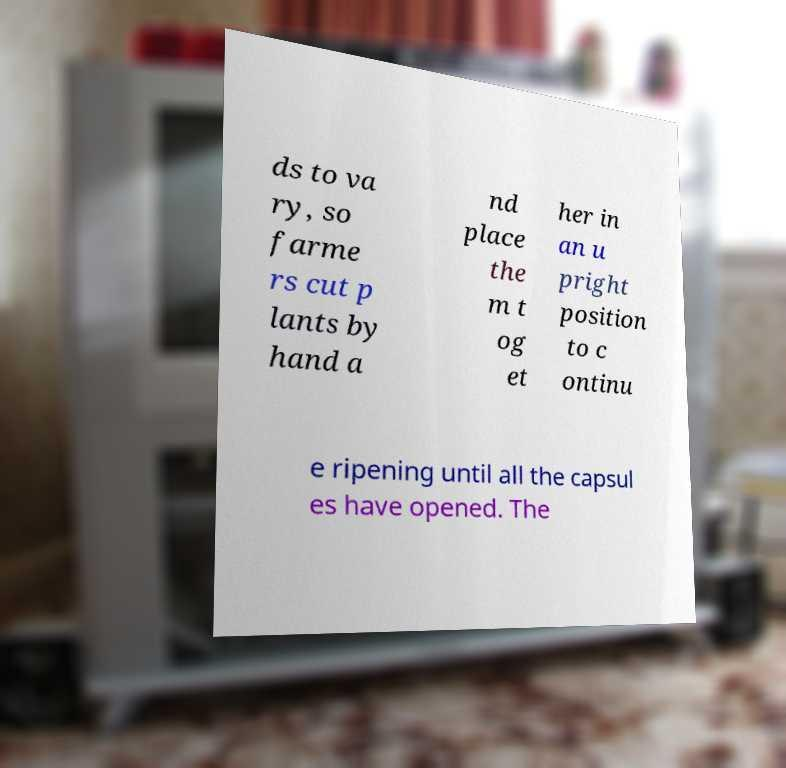Can you accurately transcribe the text from the provided image for me? ds to va ry, so farme rs cut p lants by hand a nd place the m t og et her in an u pright position to c ontinu e ripening until all the capsul es have opened. The 